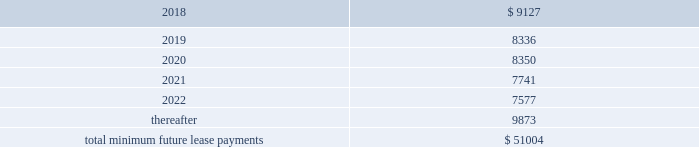As of december 31 , 2017 , the aggregate future minimum payments under non-cancelable operating leases consist of the following ( in thousands ) : years ending december 31 .
Rent expense for all operating leases amounted to $ 9.4 million , $ 8.1 million and $ 5.4 million for the years ended december 31 , 2017 , 2016 and 2015 , respectively .
Financing obligation 2014build-to-suit lease in august 2012 , we executed a lease for a building then under construction in santa clara , california to serve as our headquarters .
The lease term is 120 months and commenced in august 2013 .
Based on the terms of the lease agreement and due to our involvement in certain aspects of the construction , we were deemed the owner of the building ( for accounting purposes only ) during the construction period .
Upon completion of construction in 2013 , we concluded that we had forms of continued economic involvement in the facility , and therefore did not meet with the provisions for sale-leaseback accounting .
We continue to maintain involvement in the property post construction and lack transferability of the risks and rewards of ownership , due to our required maintenance of a $ 4.0 million letter of credit , in addition to our ability and option to sublease our portion of the leased building for fees substantially higher than our base rate .
Therefore , the lease is accounted for as a financing obligation and lease payments will be attributed to ( 1 ) a reduction of the principal financing obligation ; ( 2 ) imputed interest expense ; and ( 3 ) land lease expense , representing an imputed cost to lease the underlying land of the building .
At the conclusion of the initial lease term , we will de-recognize both the net book values of the asset and the remaining financing obligation .
As of december 31 , 2017 and 2016 , we have recorded assets of $ 53.4 million , representing the total costs of the building and improvements incurred , including the costs paid by the lessor ( the legal owner of the building ) and additional improvement costs paid by us , and a corresponding financing obligation of $ 39.6 million and $ 41.2 million , respectively .
As of december 31 , 2017 , $ 1.9 million and $ 37.7 million were recorded as short-term and long-term financing obligations , respectively .
Land lease expense under our lease financing obligation amounted to $ 1.3 million for each of the years ended december 31 , 2017 , 2016 and 2015 respectively. .
What is the total rent expense for the period from december 31 , 2017 , 2016 and 2015 in millions? 
Computations: ((9.4 + 8.1) + 5.4)
Answer: 22.9. 